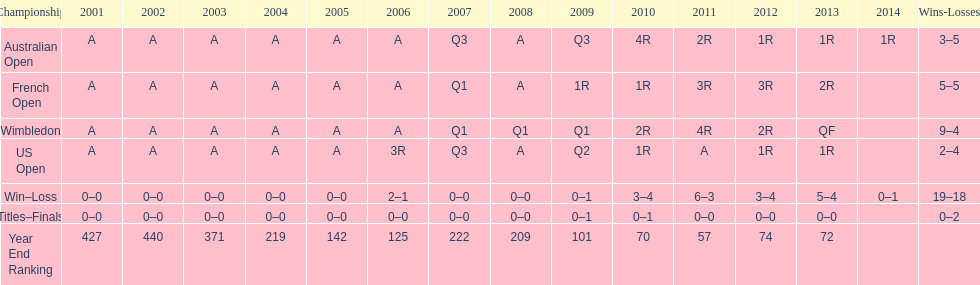Would you be able to parse every entry in this table? {'header': ['Championship', '2001', '2002', '2003', '2004', '2005', '2006', '2007', '2008', '2009', '2010', '2011', '2012', '2013', '2014', 'Wins-Losses'], 'rows': [['Australian Open', 'A', 'A', 'A', 'A', 'A', 'A', 'Q3', 'A', 'Q3', '4R', '2R', '1R', '1R', '1R', '3–5'], ['French Open', 'A', 'A', 'A', 'A', 'A', 'A', 'Q1', 'A', '1R', '1R', '3R', '3R', '2R', '', '5–5'], ['Wimbledon', 'A', 'A', 'A', 'A', 'A', 'A', 'Q1', 'Q1', 'Q1', '2R', '4R', '2R', 'QF', '', '9–4'], ['US Open', 'A', 'A', 'A', 'A', 'A', '3R', 'Q3', 'A', 'Q2', '1R', 'A', '1R', '1R', '', '2–4'], ['Win–Loss', '0–0', '0–0', '0–0', '0–0', '0–0', '2–1', '0–0', '0–0', '0–1', '3–4', '6–3', '3–4', '5–4', '0–1', '19–18'], ['Titles–Finals', '0–0', '0–0', '0–0', '0–0', '0–0', '0–0', '0–0', '0–0', '0–1', '0–1', '0–0', '0–0', '0–0', '', '0–2'], ['Year End Ranking', '427', '440', '371', '219', '142', '125', '222', '209', '101', '70', '57', '74', '72', '', '']]} In which years were there only 1 loss? 2006, 2009, 2014. 